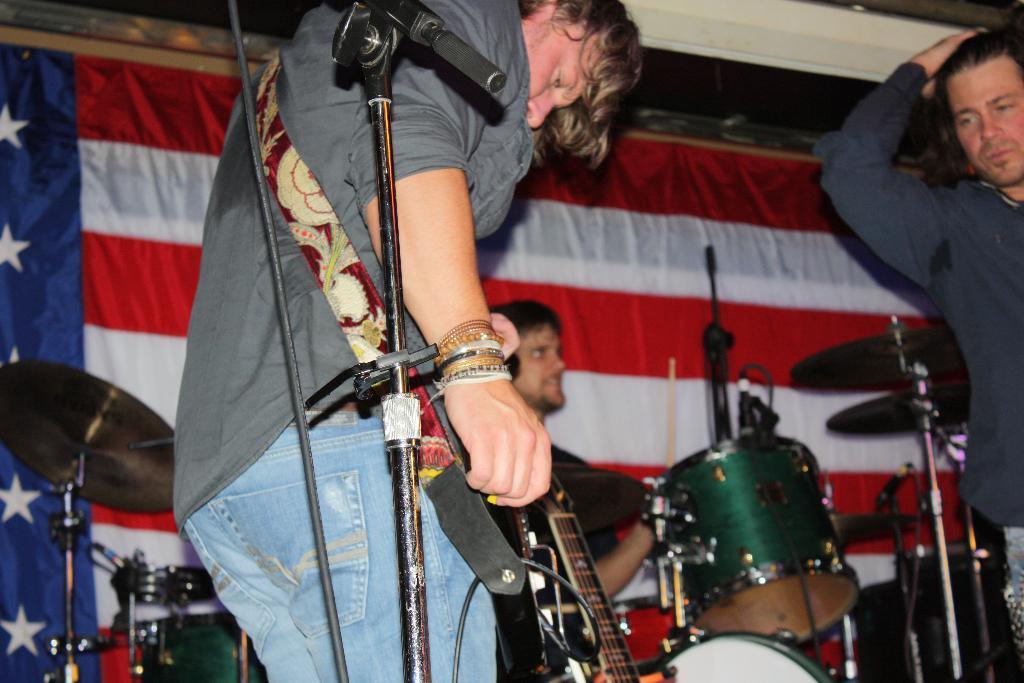Can you describe this image briefly? In this picture there is a boy who is standing in the center of the image, by holding a guitar in his hands, there is a mic on the left side of the image and there is another man who is standing on the right side of the image, there is a flag and drum set in the background area of the image. 